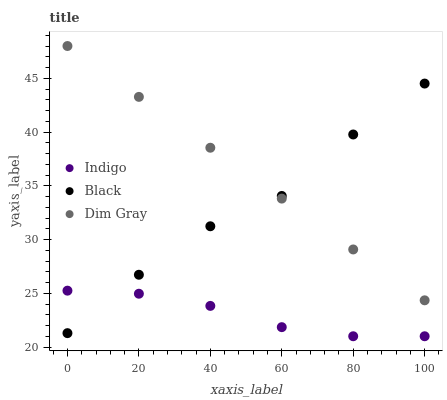Does Indigo have the minimum area under the curve?
Answer yes or no. Yes. Does Dim Gray have the maximum area under the curve?
Answer yes or no. Yes. Does Dim Gray have the minimum area under the curve?
Answer yes or no. No. Does Indigo have the maximum area under the curve?
Answer yes or no. No. Is Dim Gray the smoothest?
Answer yes or no. Yes. Is Black the roughest?
Answer yes or no. Yes. Is Indigo the smoothest?
Answer yes or no. No. Is Indigo the roughest?
Answer yes or no. No. Does Indigo have the lowest value?
Answer yes or no. Yes. Does Dim Gray have the lowest value?
Answer yes or no. No. Does Dim Gray have the highest value?
Answer yes or no. Yes. Does Indigo have the highest value?
Answer yes or no. No. Is Indigo less than Dim Gray?
Answer yes or no. Yes. Is Dim Gray greater than Indigo?
Answer yes or no. Yes. Does Indigo intersect Black?
Answer yes or no. Yes. Is Indigo less than Black?
Answer yes or no. No. Is Indigo greater than Black?
Answer yes or no. No. Does Indigo intersect Dim Gray?
Answer yes or no. No. 